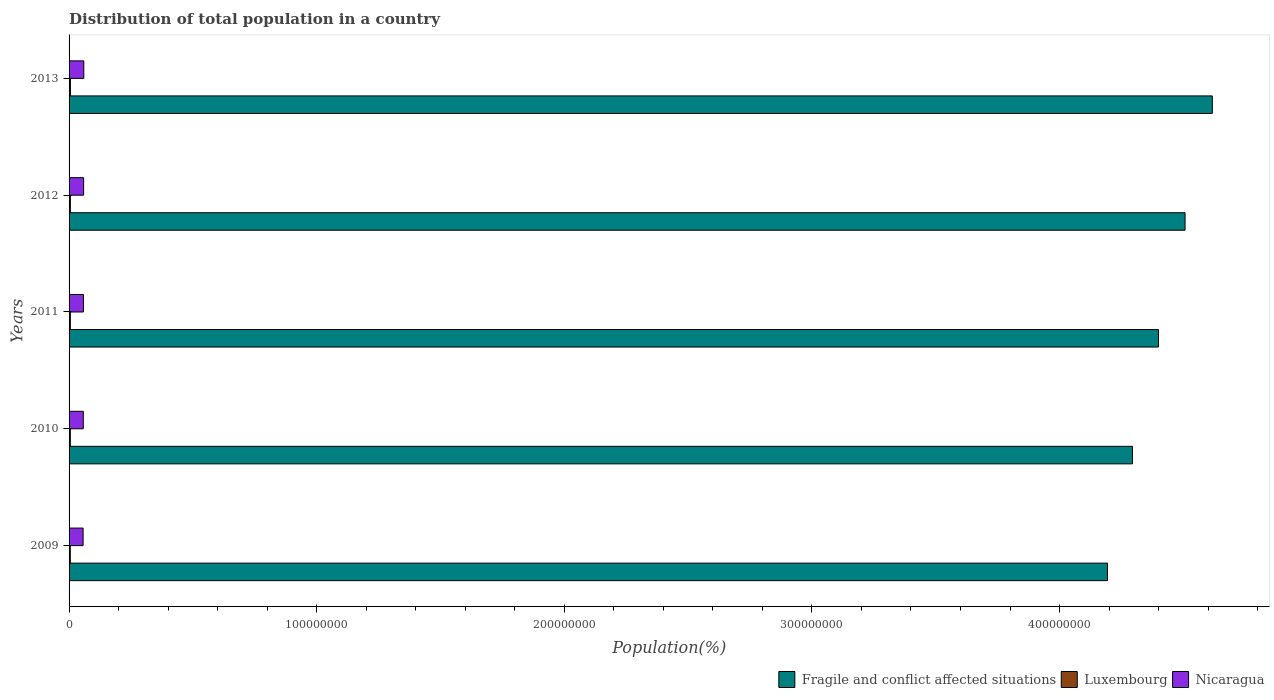How many different coloured bars are there?
Provide a succinct answer. 3. Are the number of bars on each tick of the Y-axis equal?
Your answer should be very brief. Yes. In how many cases, is the number of bars for a given year not equal to the number of legend labels?
Your response must be concise. 0. What is the population of in Fragile and conflict affected situations in 2010?
Your answer should be compact. 4.29e+08. Across all years, what is the maximum population of in Nicaragua?
Make the answer very short. 5.95e+06. Across all years, what is the minimum population of in Nicaragua?
Your answer should be compact. 5.67e+06. In which year was the population of in Luxembourg maximum?
Offer a terse response. 2013. In which year was the population of in Luxembourg minimum?
Make the answer very short. 2009. What is the total population of in Fragile and conflict affected situations in the graph?
Your response must be concise. 2.20e+09. What is the difference between the population of in Nicaragua in 2011 and that in 2013?
Provide a short and direct response. -1.38e+05. What is the difference between the population of in Luxembourg in 2009 and the population of in Nicaragua in 2013?
Give a very brief answer. -5.45e+06. What is the average population of in Luxembourg per year?
Your answer should be compact. 5.19e+05. In the year 2010, what is the difference between the population of in Luxembourg and population of in Nicaragua?
Your answer should be compact. -5.23e+06. In how many years, is the population of in Luxembourg greater than 120000000 %?
Your answer should be compact. 0. What is the ratio of the population of in Nicaragua in 2010 to that in 2011?
Provide a short and direct response. 0.99. What is the difference between the highest and the second highest population of in Nicaragua?
Your answer should be compact. 6.86e+04. What is the difference between the highest and the lowest population of in Fragile and conflict affected situations?
Make the answer very short. 4.23e+07. In how many years, is the population of in Fragile and conflict affected situations greater than the average population of in Fragile and conflict affected situations taken over all years?
Make the answer very short. 2. What does the 2nd bar from the top in 2010 represents?
Provide a short and direct response. Luxembourg. What does the 1st bar from the bottom in 2011 represents?
Give a very brief answer. Fragile and conflict affected situations. Is it the case that in every year, the sum of the population of in Nicaragua and population of in Luxembourg is greater than the population of in Fragile and conflict affected situations?
Ensure brevity in your answer.  No. How many bars are there?
Offer a terse response. 15. Are all the bars in the graph horizontal?
Offer a very short reply. Yes. Does the graph contain grids?
Your answer should be very brief. No. Where does the legend appear in the graph?
Give a very brief answer. Bottom right. How many legend labels are there?
Keep it short and to the point. 3. What is the title of the graph?
Offer a very short reply. Distribution of total population in a country. What is the label or title of the X-axis?
Keep it short and to the point. Population(%). What is the label or title of the Y-axis?
Offer a terse response. Years. What is the Population(%) in Fragile and conflict affected situations in 2009?
Your answer should be compact. 4.19e+08. What is the Population(%) in Luxembourg in 2009?
Provide a succinct answer. 4.98e+05. What is the Population(%) in Nicaragua in 2009?
Your response must be concise. 5.67e+06. What is the Population(%) in Fragile and conflict affected situations in 2010?
Your response must be concise. 4.29e+08. What is the Population(%) in Luxembourg in 2010?
Keep it short and to the point. 5.07e+05. What is the Population(%) in Nicaragua in 2010?
Keep it short and to the point. 5.74e+06. What is the Population(%) in Fragile and conflict affected situations in 2011?
Provide a short and direct response. 4.40e+08. What is the Population(%) of Luxembourg in 2011?
Provide a short and direct response. 5.18e+05. What is the Population(%) of Nicaragua in 2011?
Keep it short and to the point. 5.81e+06. What is the Population(%) of Fragile and conflict affected situations in 2012?
Offer a terse response. 4.51e+08. What is the Population(%) in Luxembourg in 2012?
Make the answer very short. 5.31e+05. What is the Population(%) of Nicaragua in 2012?
Offer a terse response. 5.88e+06. What is the Population(%) of Fragile and conflict affected situations in 2013?
Keep it short and to the point. 4.62e+08. What is the Population(%) in Luxembourg in 2013?
Keep it short and to the point. 5.43e+05. What is the Population(%) in Nicaragua in 2013?
Ensure brevity in your answer.  5.95e+06. Across all years, what is the maximum Population(%) in Fragile and conflict affected situations?
Provide a succinct answer. 4.62e+08. Across all years, what is the maximum Population(%) in Luxembourg?
Provide a short and direct response. 5.43e+05. Across all years, what is the maximum Population(%) of Nicaragua?
Provide a succinct answer. 5.95e+06. Across all years, what is the minimum Population(%) in Fragile and conflict affected situations?
Ensure brevity in your answer.  4.19e+08. Across all years, what is the minimum Population(%) in Luxembourg?
Keep it short and to the point. 4.98e+05. Across all years, what is the minimum Population(%) in Nicaragua?
Ensure brevity in your answer.  5.67e+06. What is the total Population(%) of Fragile and conflict affected situations in the graph?
Offer a terse response. 2.20e+09. What is the total Population(%) in Luxembourg in the graph?
Your answer should be very brief. 2.60e+06. What is the total Population(%) of Nicaragua in the graph?
Your answer should be compact. 2.90e+07. What is the difference between the Population(%) in Fragile and conflict affected situations in 2009 and that in 2010?
Your answer should be very brief. -1.01e+07. What is the difference between the Population(%) of Luxembourg in 2009 and that in 2010?
Your response must be concise. -9170. What is the difference between the Population(%) in Nicaragua in 2009 and that in 2010?
Ensure brevity in your answer.  -7.11e+04. What is the difference between the Population(%) of Fragile and conflict affected situations in 2009 and that in 2011?
Give a very brief answer. -2.06e+07. What is the difference between the Population(%) of Luxembourg in 2009 and that in 2011?
Your answer should be very brief. -2.06e+04. What is the difference between the Population(%) of Nicaragua in 2009 and that in 2011?
Provide a short and direct response. -1.41e+05. What is the difference between the Population(%) in Fragile and conflict affected situations in 2009 and that in 2012?
Give a very brief answer. -3.13e+07. What is the difference between the Population(%) in Luxembourg in 2009 and that in 2012?
Your answer should be compact. -3.32e+04. What is the difference between the Population(%) of Nicaragua in 2009 and that in 2012?
Offer a very short reply. -2.10e+05. What is the difference between the Population(%) in Fragile and conflict affected situations in 2009 and that in 2013?
Provide a succinct answer. -4.23e+07. What is the difference between the Population(%) in Luxembourg in 2009 and that in 2013?
Provide a succinct answer. -4.56e+04. What is the difference between the Population(%) of Nicaragua in 2009 and that in 2013?
Provide a short and direct response. -2.79e+05. What is the difference between the Population(%) in Fragile and conflict affected situations in 2010 and that in 2011?
Offer a terse response. -1.05e+07. What is the difference between the Population(%) in Luxembourg in 2010 and that in 2011?
Keep it short and to the point. -1.14e+04. What is the difference between the Population(%) in Nicaragua in 2010 and that in 2011?
Your answer should be very brief. -7.01e+04. What is the difference between the Population(%) of Fragile and conflict affected situations in 2010 and that in 2012?
Give a very brief answer. -2.13e+07. What is the difference between the Population(%) of Luxembourg in 2010 and that in 2012?
Keep it short and to the point. -2.40e+04. What is the difference between the Population(%) of Nicaragua in 2010 and that in 2012?
Offer a very short reply. -1.39e+05. What is the difference between the Population(%) in Fragile and conflict affected situations in 2010 and that in 2013?
Keep it short and to the point. -3.23e+07. What is the difference between the Population(%) in Luxembourg in 2010 and that in 2013?
Offer a very short reply. -3.64e+04. What is the difference between the Population(%) in Nicaragua in 2010 and that in 2013?
Your response must be concise. -2.08e+05. What is the difference between the Population(%) in Fragile and conflict affected situations in 2011 and that in 2012?
Keep it short and to the point. -1.07e+07. What is the difference between the Population(%) of Luxembourg in 2011 and that in 2012?
Give a very brief answer. -1.26e+04. What is the difference between the Population(%) of Nicaragua in 2011 and that in 2012?
Offer a terse response. -6.92e+04. What is the difference between the Population(%) of Fragile and conflict affected situations in 2011 and that in 2013?
Your answer should be compact. -2.18e+07. What is the difference between the Population(%) of Luxembourg in 2011 and that in 2013?
Your response must be concise. -2.50e+04. What is the difference between the Population(%) of Nicaragua in 2011 and that in 2013?
Make the answer very short. -1.38e+05. What is the difference between the Population(%) in Fragile and conflict affected situations in 2012 and that in 2013?
Provide a short and direct response. -1.10e+07. What is the difference between the Population(%) of Luxembourg in 2012 and that in 2013?
Provide a succinct answer. -1.24e+04. What is the difference between the Population(%) in Nicaragua in 2012 and that in 2013?
Your response must be concise. -6.86e+04. What is the difference between the Population(%) in Fragile and conflict affected situations in 2009 and the Population(%) in Luxembourg in 2010?
Give a very brief answer. 4.19e+08. What is the difference between the Population(%) of Fragile and conflict affected situations in 2009 and the Population(%) of Nicaragua in 2010?
Your answer should be very brief. 4.14e+08. What is the difference between the Population(%) of Luxembourg in 2009 and the Population(%) of Nicaragua in 2010?
Your answer should be compact. -5.24e+06. What is the difference between the Population(%) in Fragile and conflict affected situations in 2009 and the Population(%) in Luxembourg in 2011?
Ensure brevity in your answer.  4.19e+08. What is the difference between the Population(%) of Fragile and conflict affected situations in 2009 and the Population(%) of Nicaragua in 2011?
Keep it short and to the point. 4.14e+08. What is the difference between the Population(%) of Luxembourg in 2009 and the Population(%) of Nicaragua in 2011?
Give a very brief answer. -5.31e+06. What is the difference between the Population(%) in Fragile and conflict affected situations in 2009 and the Population(%) in Luxembourg in 2012?
Keep it short and to the point. 4.19e+08. What is the difference between the Population(%) of Fragile and conflict affected situations in 2009 and the Population(%) of Nicaragua in 2012?
Keep it short and to the point. 4.13e+08. What is the difference between the Population(%) in Luxembourg in 2009 and the Population(%) in Nicaragua in 2012?
Keep it short and to the point. -5.38e+06. What is the difference between the Population(%) of Fragile and conflict affected situations in 2009 and the Population(%) of Luxembourg in 2013?
Ensure brevity in your answer.  4.19e+08. What is the difference between the Population(%) in Fragile and conflict affected situations in 2009 and the Population(%) in Nicaragua in 2013?
Offer a very short reply. 4.13e+08. What is the difference between the Population(%) of Luxembourg in 2009 and the Population(%) of Nicaragua in 2013?
Provide a short and direct response. -5.45e+06. What is the difference between the Population(%) in Fragile and conflict affected situations in 2010 and the Population(%) in Luxembourg in 2011?
Provide a succinct answer. 4.29e+08. What is the difference between the Population(%) in Fragile and conflict affected situations in 2010 and the Population(%) in Nicaragua in 2011?
Offer a very short reply. 4.24e+08. What is the difference between the Population(%) in Luxembourg in 2010 and the Population(%) in Nicaragua in 2011?
Your response must be concise. -5.30e+06. What is the difference between the Population(%) in Fragile and conflict affected situations in 2010 and the Population(%) in Luxembourg in 2012?
Your response must be concise. 4.29e+08. What is the difference between the Population(%) in Fragile and conflict affected situations in 2010 and the Population(%) in Nicaragua in 2012?
Make the answer very short. 4.24e+08. What is the difference between the Population(%) of Luxembourg in 2010 and the Population(%) of Nicaragua in 2012?
Your answer should be very brief. -5.37e+06. What is the difference between the Population(%) of Fragile and conflict affected situations in 2010 and the Population(%) of Luxembourg in 2013?
Ensure brevity in your answer.  4.29e+08. What is the difference between the Population(%) of Fragile and conflict affected situations in 2010 and the Population(%) of Nicaragua in 2013?
Provide a succinct answer. 4.24e+08. What is the difference between the Population(%) in Luxembourg in 2010 and the Population(%) in Nicaragua in 2013?
Provide a short and direct response. -5.44e+06. What is the difference between the Population(%) in Fragile and conflict affected situations in 2011 and the Population(%) in Luxembourg in 2012?
Provide a short and direct response. 4.39e+08. What is the difference between the Population(%) in Fragile and conflict affected situations in 2011 and the Population(%) in Nicaragua in 2012?
Your answer should be compact. 4.34e+08. What is the difference between the Population(%) of Luxembourg in 2011 and the Population(%) of Nicaragua in 2012?
Keep it short and to the point. -5.36e+06. What is the difference between the Population(%) of Fragile and conflict affected situations in 2011 and the Population(%) of Luxembourg in 2013?
Your answer should be very brief. 4.39e+08. What is the difference between the Population(%) in Fragile and conflict affected situations in 2011 and the Population(%) in Nicaragua in 2013?
Keep it short and to the point. 4.34e+08. What is the difference between the Population(%) in Luxembourg in 2011 and the Population(%) in Nicaragua in 2013?
Ensure brevity in your answer.  -5.43e+06. What is the difference between the Population(%) in Fragile and conflict affected situations in 2012 and the Population(%) in Luxembourg in 2013?
Your answer should be compact. 4.50e+08. What is the difference between the Population(%) of Fragile and conflict affected situations in 2012 and the Population(%) of Nicaragua in 2013?
Your answer should be very brief. 4.45e+08. What is the difference between the Population(%) in Luxembourg in 2012 and the Population(%) in Nicaragua in 2013?
Provide a short and direct response. -5.41e+06. What is the average Population(%) in Fragile and conflict affected situations per year?
Provide a short and direct response. 4.40e+08. What is the average Population(%) of Luxembourg per year?
Your answer should be compact. 5.19e+05. What is the average Population(%) of Nicaragua per year?
Keep it short and to the point. 5.81e+06. In the year 2009, what is the difference between the Population(%) in Fragile and conflict affected situations and Population(%) in Luxembourg?
Provide a succinct answer. 4.19e+08. In the year 2009, what is the difference between the Population(%) in Fragile and conflict affected situations and Population(%) in Nicaragua?
Keep it short and to the point. 4.14e+08. In the year 2009, what is the difference between the Population(%) in Luxembourg and Population(%) in Nicaragua?
Give a very brief answer. -5.17e+06. In the year 2010, what is the difference between the Population(%) in Fragile and conflict affected situations and Population(%) in Luxembourg?
Offer a very short reply. 4.29e+08. In the year 2010, what is the difference between the Population(%) of Fragile and conflict affected situations and Population(%) of Nicaragua?
Ensure brevity in your answer.  4.24e+08. In the year 2010, what is the difference between the Population(%) of Luxembourg and Population(%) of Nicaragua?
Offer a terse response. -5.23e+06. In the year 2011, what is the difference between the Population(%) in Fragile and conflict affected situations and Population(%) in Luxembourg?
Provide a short and direct response. 4.39e+08. In the year 2011, what is the difference between the Population(%) in Fragile and conflict affected situations and Population(%) in Nicaragua?
Provide a short and direct response. 4.34e+08. In the year 2011, what is the difference between the Population(%) in Luxembourg and Population(%) in Nicaragua?
Ensure brevity in your answer.  -5.29e+06. In the year 2012, what is the difference between the Population(%) in Fragile and conflict affected situations and Population(%) in Luxembourg?
Your answer should be compact. 4.50e+08. In the year 2012, what is the difference between the Population(%) in Fragile and conflict affected situations and Population(%) in Nicaragua?
Make the answer very short. 4.45e+08. In the year 2012, what is the difference between the Population(%) in Luxembourg and Population(%) in Nicaragua?
Make the answer very short. -5.35e+06. In the year 2013, what is the difference between the Population(%) of Fragile and conflict affected situations and Population(%) of Luxembourg?
Your response must be concise. 4.61e+08. In the year 2013, what is the difference between the Population(%) in Fragile and conflict affected situations and Population(%) in Nicaragua?
Provide a succinct answer. 4.56e+08. In the year 2013, what is the difference between the Population(%) of Luxembourg and Population(%) of Nicaragua?
Provide a short and direct response. -5.40e+06. What is the ratio of the Population(%) in Fragile and conflict affected situations in 2009 to that in 2010?
Ensure brevity in your answer.  0.98. What is the ratio of the Population(%) of Luxembourg in 2009 to that in 2010?
Keep it short and to the point. 0.98. What is the ratio of the Population(%) in Nicaragua in 2009 to that in 2010?
Give a very brief answer. 0.99. What is the ratio of the Population(%) of Fragile and conflict affected situations in 2009 to that in 2011?
Provide a short and direct response. 0.95. What is the ratio of the Population(%) of Luxembourg in 2009 to that in 2011?
Provide a succinct answer. 0.96. What is the ratio of the Population(%) of Nicaragua in 2009 to that in 2011?
Make the answer very short. 0.98. What is the ratio of the Population(%) in Fragile and conflict affected situations in 2009 to that in 2012?
Your answer should be compact. 0.93. What is the ratio of the Population(%) in Luxembourg in 2009 to that in 2012?
Your answer should be very brief. 0.94. What is the ratio of the Population(%) in Nicaragua in 2009 to that in 2012?
Ensure brevity in your answer.  0.96. What is the ratio of the Population(%) of Fragile and conflict affected situations in 2009 to that in 2013?
Offer a terse response. 0.91. What is the ratio of the Population(%) in Luxembourg in 2009 to that in 2013?
Offer a very short reply. 0.92. What is the ratio of the Population(%) in Nicaragua in 2009 to that in 2013?
Give a very brief answer. 0.95. What is the ratio of the Population(%) in Fragile and conflict affected situations in 2010 to that in 2011?
Provide a succinct answer. 0.98. What is the ratio of the Population(%) of Luxembourg in 2010 to that in 2011?
Your answer should be very brief. 0.98. What is the ratio of the Population(%) of Nicaragua in 2010 to that in 2011?
Keep it short and to the point. 0.99. What is the ratio of the Population(%) in Fragile and conflict affected situations in 2010 to that in 2012?
Provide a succinct answer. 0.95. What is the ratio of the Population(%) of Luxembourg in 2010 to that in 2012?
Offer a terse response. 0.95. What is the ratio of the Population(%) in Nicaragua in 2010 to that in 2012?
Give a very brief answer. 0.98. What is the ratio of the Population(%) in Fragile and conflict affected situations in 2010 to that in 2013?
Provide a succinct answer. 0.93. What is the ratio of the Population(%) of Luxembourg in 2010 to that in 2013?
Ensure brevity in your answer.  0.93. What is the ratio of the Population(%) in Fragile and conflict affected situations in 2011 to that in 2012?
Keep it short and to the point. 0.98. What is the ratio of the Population(%) of Luxembourg in 2011 to that in 2012?
Provide a succinct answer. 0.98. What is the ratio of the Population(%) of Fragile and conflict affected situations in 2011 to that in 2013?
Ensure brevity in your answer.  0.95. What is the ratio of the Population(%) in Luxembourg in 2011 to that in 2013?
Your response must be concise. 0.95. What is the ratio of the Population(%) of Nicaragua in 2011 to that in 2013?
Provide a short and direct response. 0.98. What is the ratio of the Population(%) of Fragile and conflict affected situations in 2012 to that in 2013?
Your response must be concise. 0.98. What is the ratio of the Population(%) in Luxembourg in 2012 to that in 2013?
Ensure brevity in your answer.  0.98. What is the difference between the highest and the second highest Population(%) of Fragile and conflict affected situations?
Make the answer very short. 1.10e+07. What is the difference between the highest and the second highest Population(%) in Luxembourg?
Your answer should be compact. 1.24e+04. What is the difference between the highest and the second highest Population(%) of Nicaragua?
Offer a terse response. 6.86e+04. What is the difference between the highest and the lowest Population(%) of Fragile and conflict affected situations?
Provide a succinct answer. 4.23e+07. What is the difference between the highest and the lowest Population(%) of Luxembourg?
Ensure brevity in your answer.  4.56e+04. What is the difference between the highest and the lowest Population(%) in Nicaragua?
Your answer should be compact. 2.79e+05. 